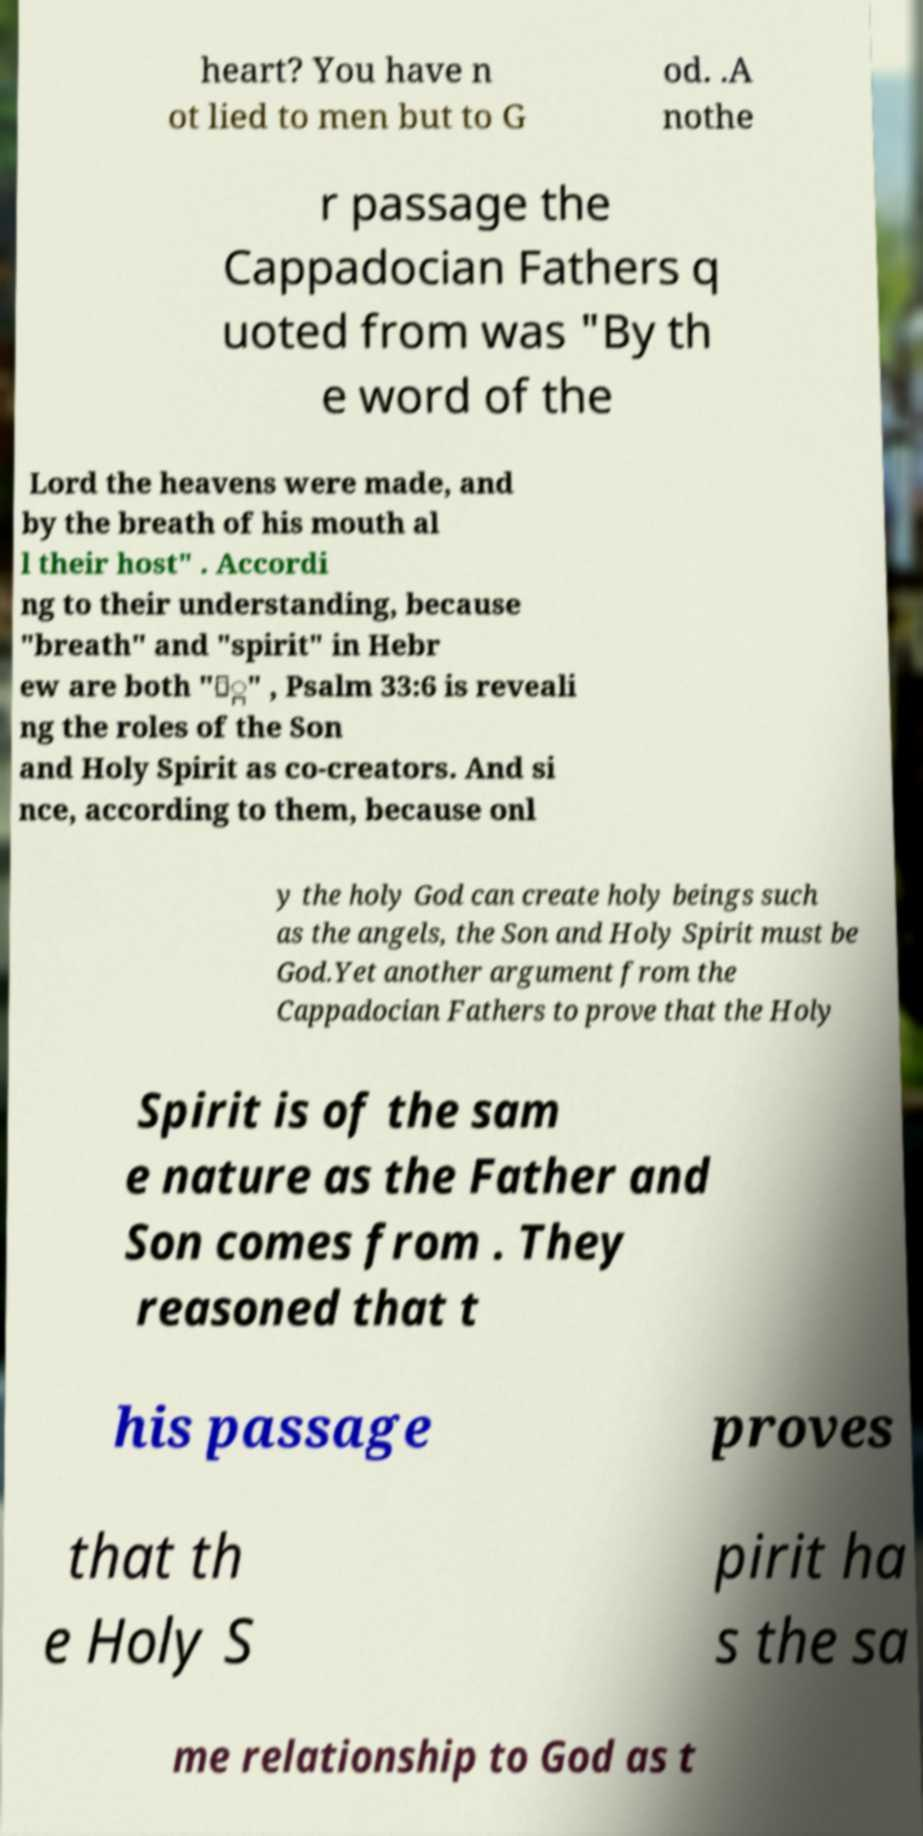Can you accurately transcribe the text from the provided image for me? heart? You have n ot lied to men but to G od. .A nothe r passage the Cappadocian Fathers q uoted from was "By th e word of the Lord the heavens were made, and by the breath of his mouth al l their host" . Accordi ng to their understanding, because "breath" and "spirit" in Hebr ew are both "ַּ" , Psalm 33:6 is reveali ng the roles of the Son and Holy Spirit as co-creators. And si nce, according to them, because onl y the holy God can create holy beings such as the angels, the Son and Holy Spirit must be God.Yet another argument from the Cappadocian Fathers to prove that the Holy Spirit is of the sam e nature as the Father and Son comes from . They reasoned that t his passage proves that th e Holy S pirit ha s the sa me relationship to God as t 